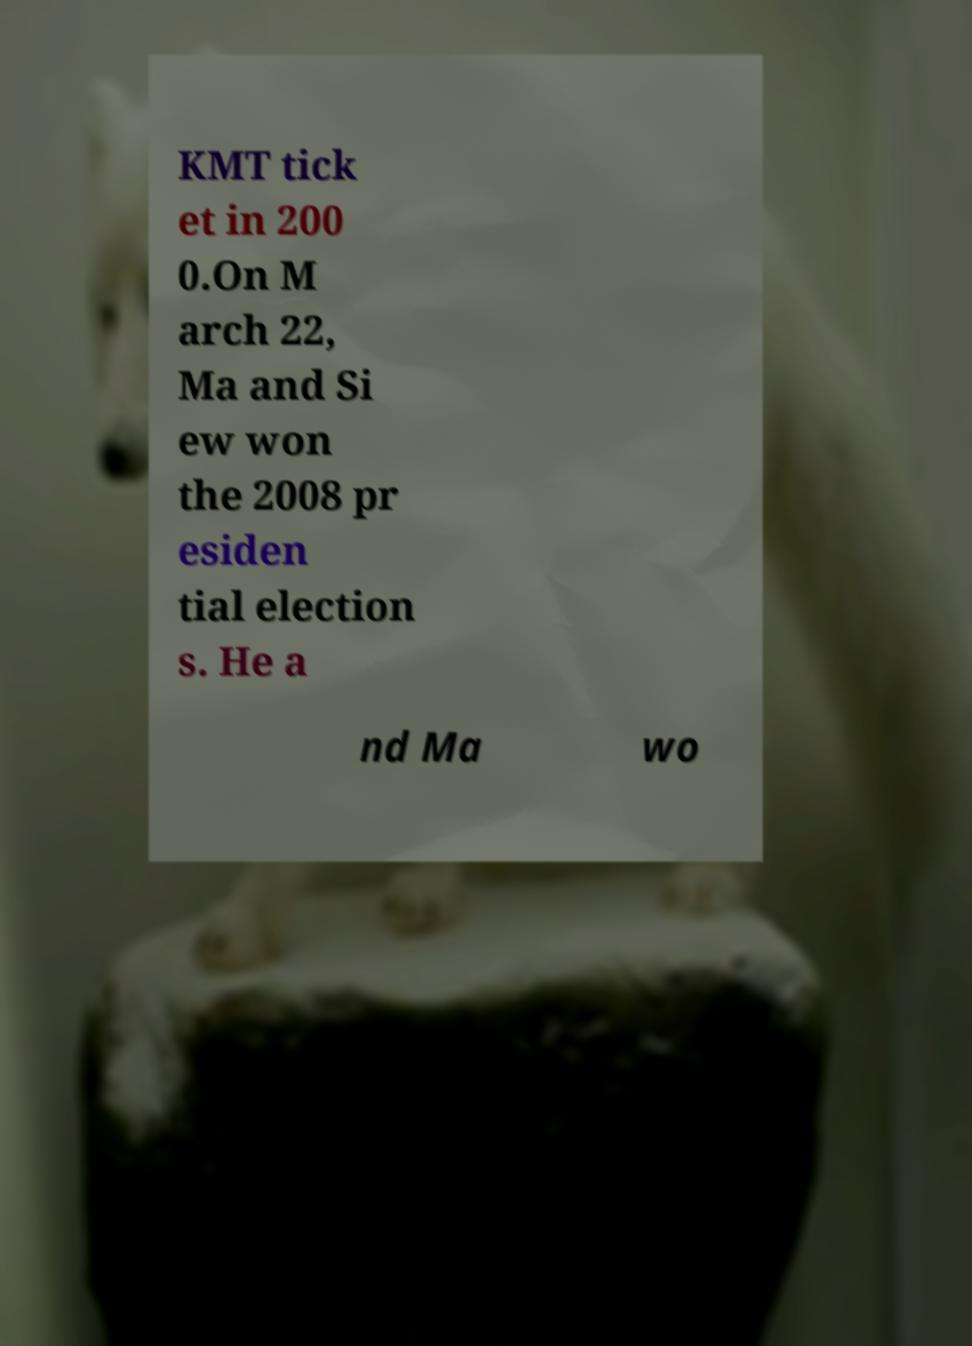Can you read and provide the text displayed in the image?This photo seems to have some interesting text. Can you extract and type it out for me? KMT tick et in 200 0.On M arch 22, Ma and Si ew won the 2008 pr esiden tial election s. He a nd Ma wo 